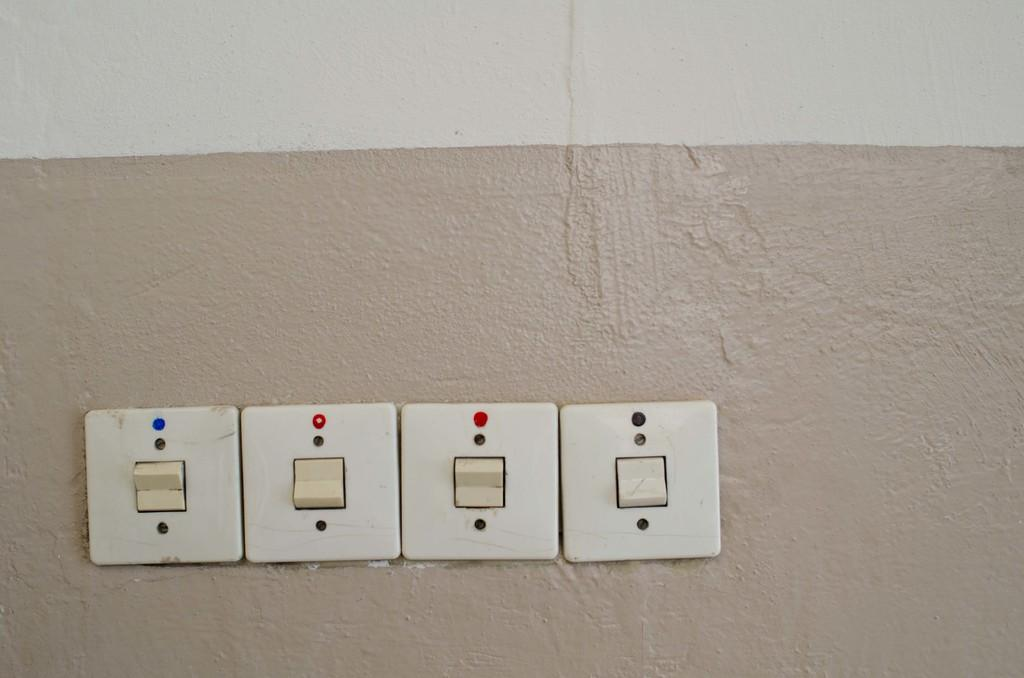How many switches are on the wall in the image? There are four switches on the wall in the image. What type of amusement can be seen in the image? There is no amusement present in the image; it only shows four switches on a wall. How many brothers are visible in the image? There are no people, including brothers, present in the image. 